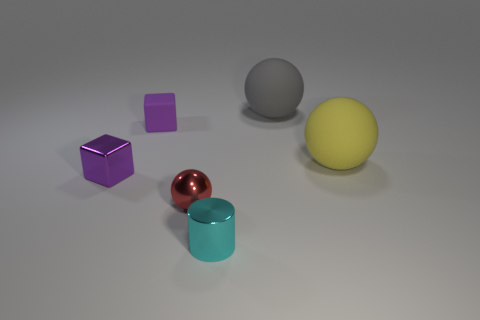There is another block that is the same color as the small metal cube; what is it made of?
Your response must be concise. Rubber. What color is the other large matte thing that is the same shape as the yellow object?
Ensure brevity in your answer.  Gray. There is a thing that is in front of the small shiny block and right of the red ball; what is its shape?
Your answer should be compact. Cylinder. Are there more yellow spheres than big blue metal blocks?
Your response must be concise. Yes. What is the material of the large yellow sphere?
Your answer should be very brief. Rubber. What is the size of the gray matte object that is the same shape as the yellow thing?
Ensure brevity in your answer.  Large. Are there any small shiny spheres that are right of the ball that is on the left side of the cylinder?
Offer a very short reply. No. Does the small matte thing have the same color as the shiny cube?
Your answer should be compact. Yes. How many other things are there of the same shape as the small red thing?
Your answer should be very brief. 2. Are there more rubber objects to the left of the tiny cylinder than yellow rubber spheres that are behind the gray sphere?
Make the answer very short. Yes. 